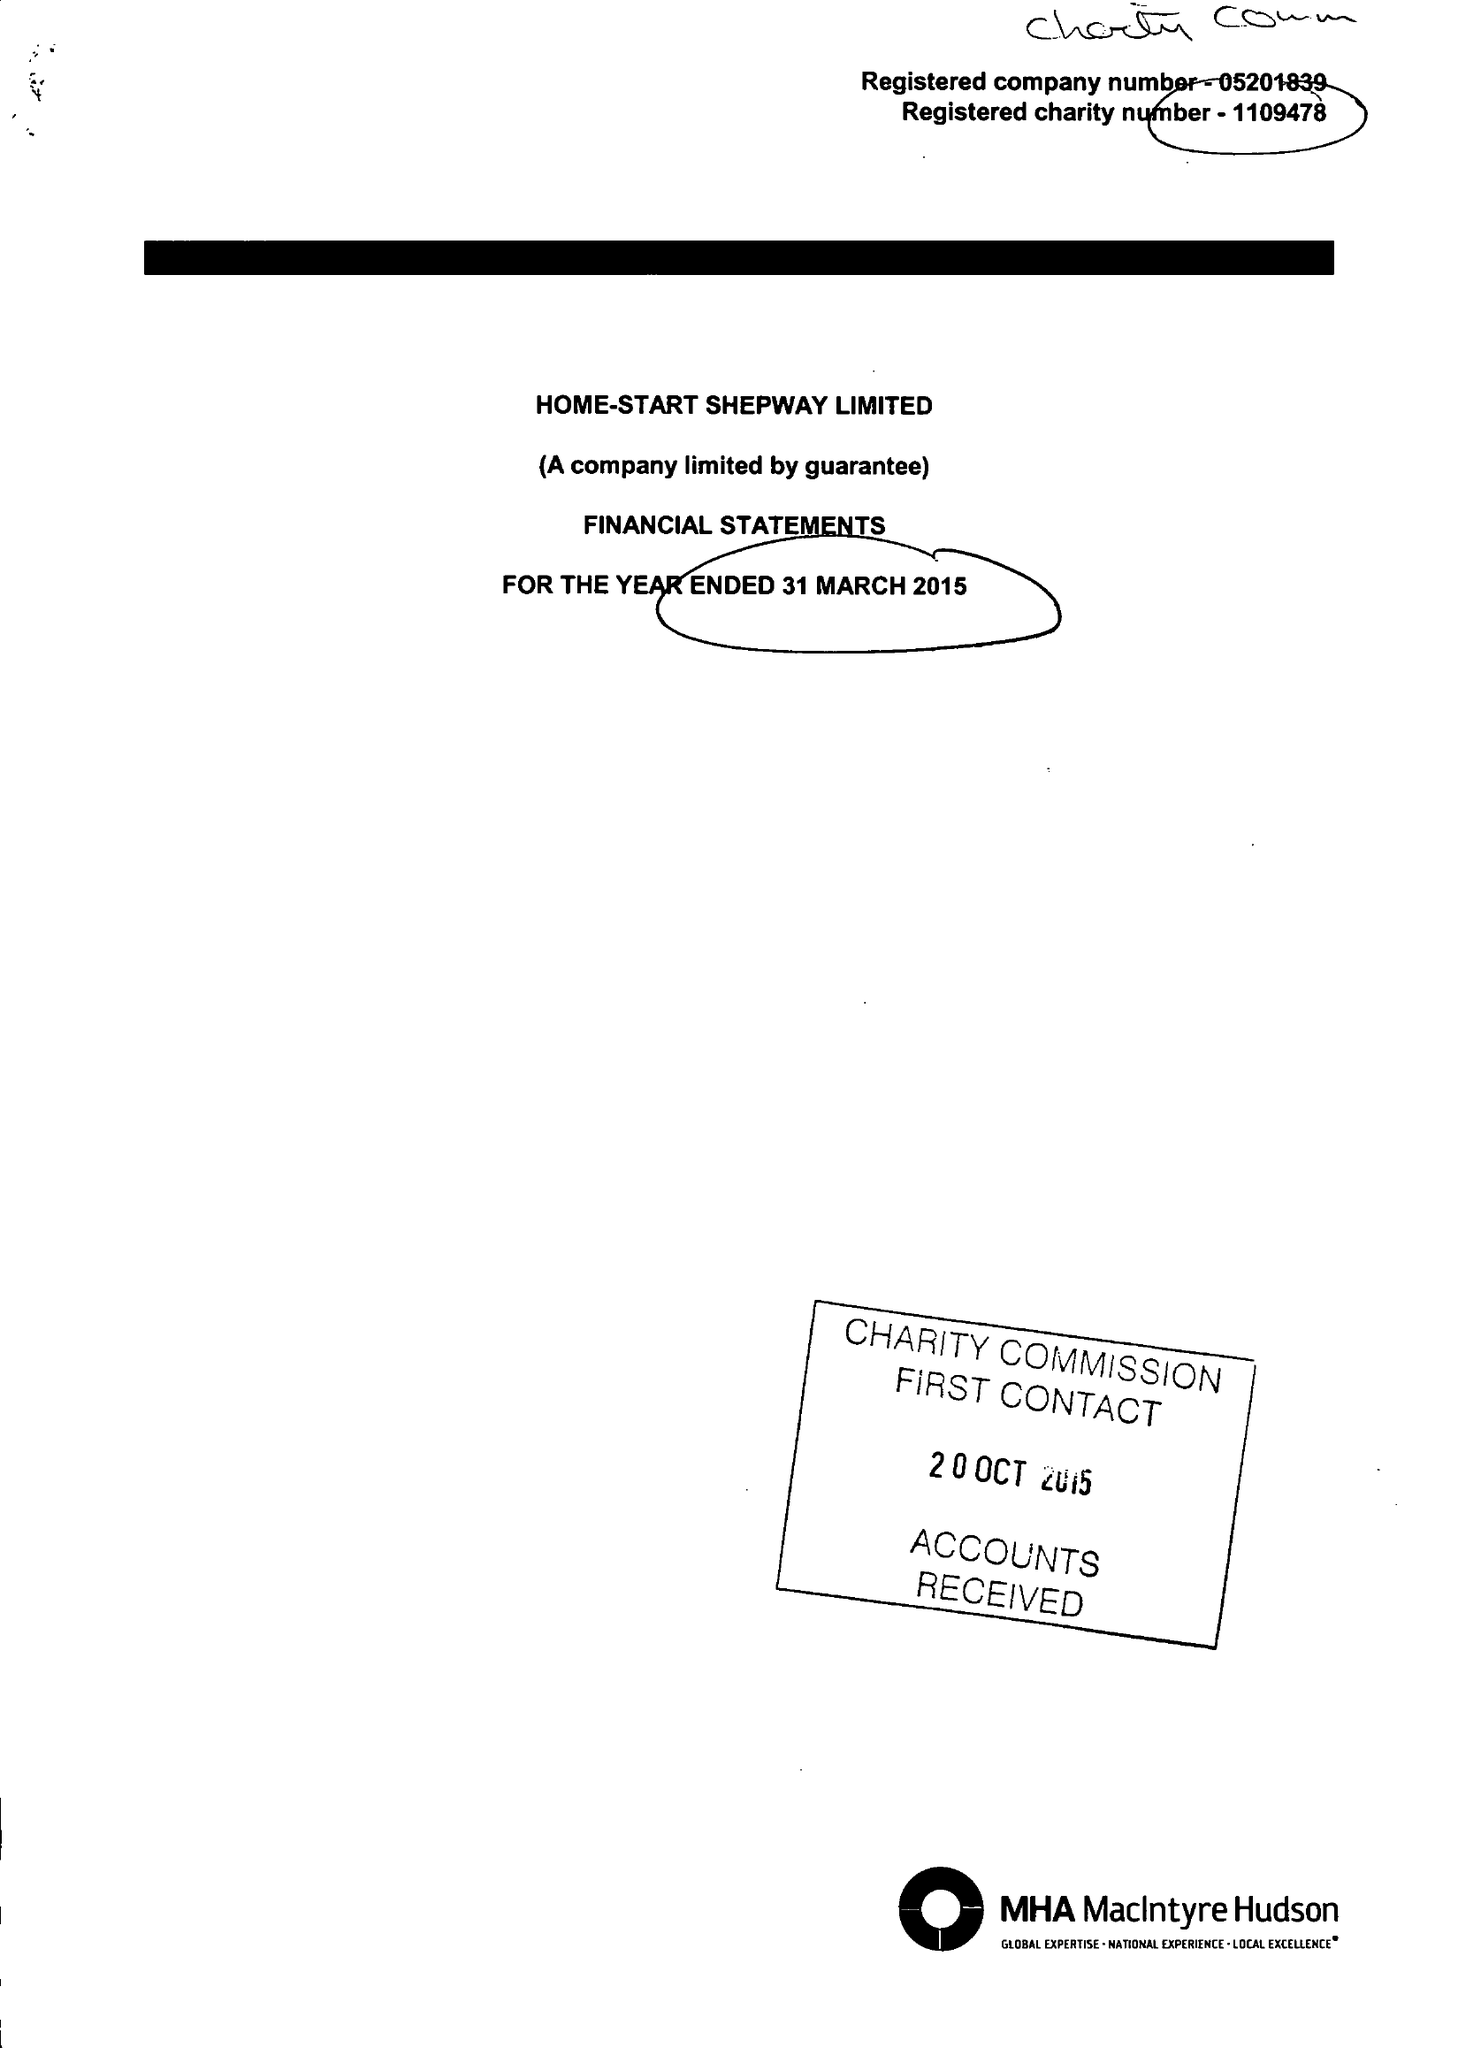What is the value for the address__postcode?
Answer the question using a single word or phrase. CT20 2AS 